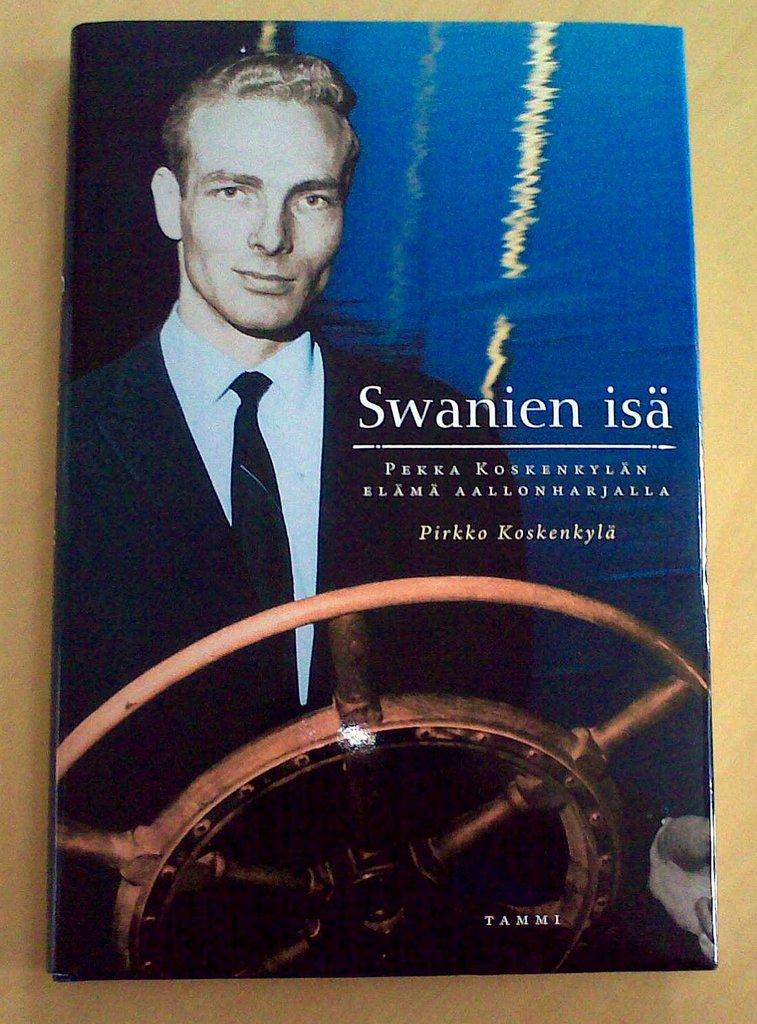<image>
Present a compact description of the photo's key features. A book named Swanien isa Pirkko Kaskenkyla is on the table. 